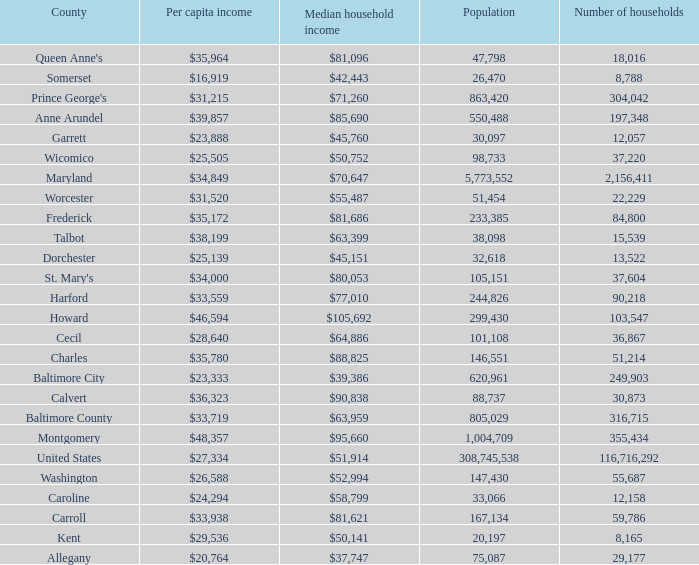What is the per capital income for Washington county? $26,588. 